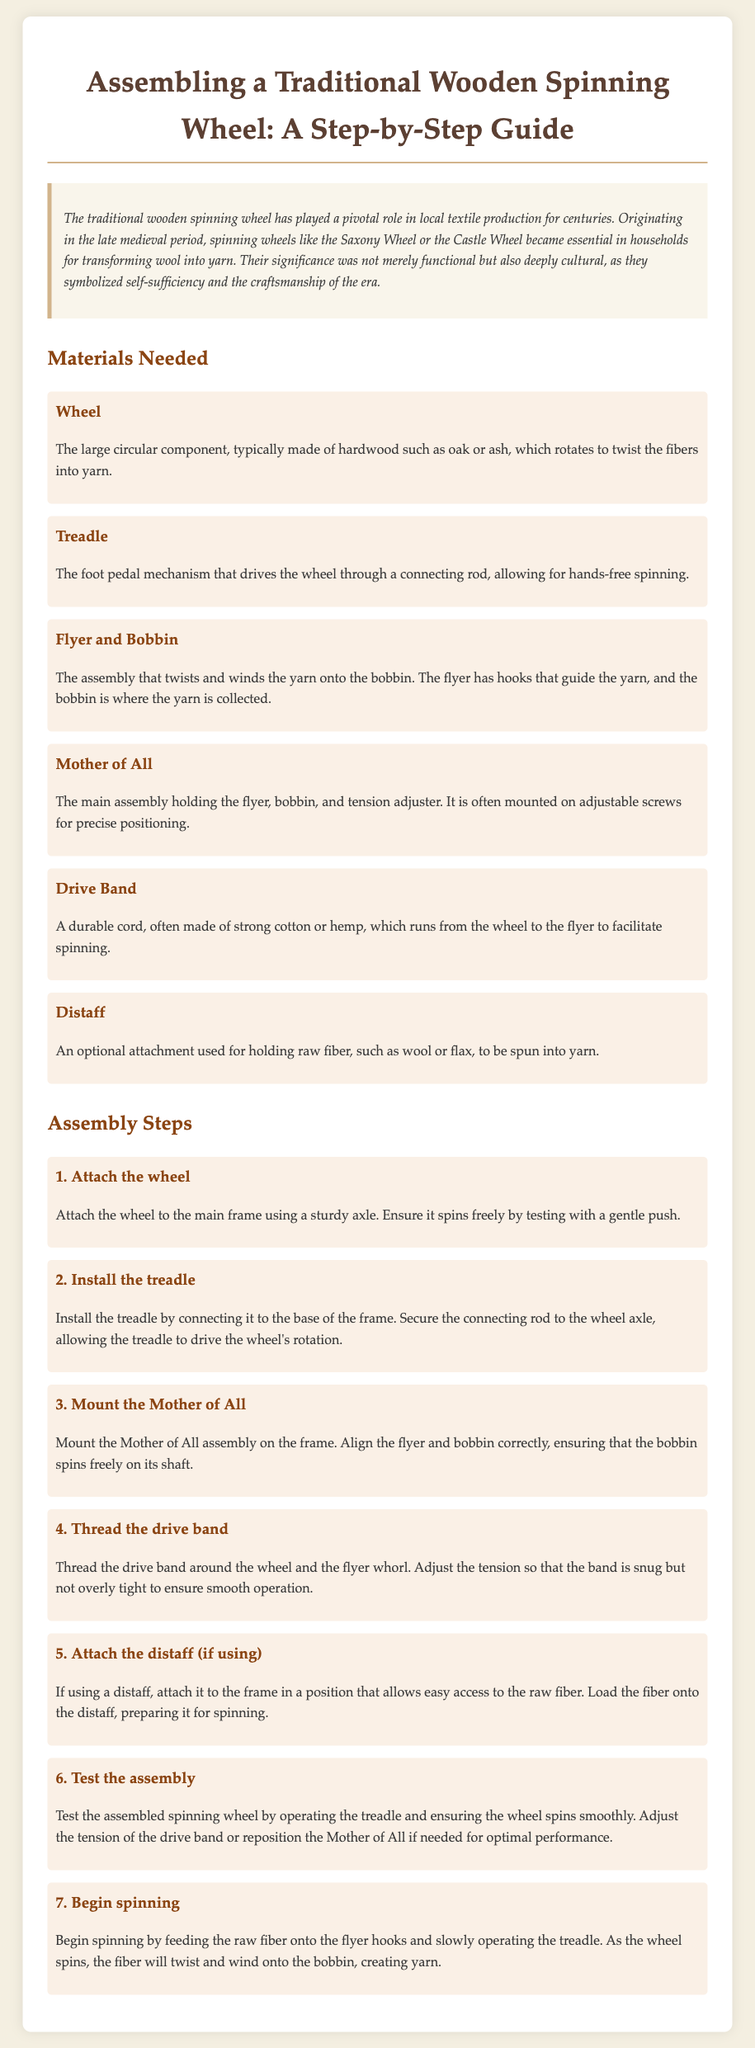what is the title of the document? The title of the document is stated prominently at the top, introducing the main topic of the content.
Answer: Assembling a Traditional Wooden Spinning Wheel: A Step-by-Step Guide what type of wood is the wheel made of? The document specifies the materials needed for assembly, mentioning the type of wood suitable for the wheel.
Answer: hardwood such as oak or ash how many assembly steps are provided in the document? The document lists each assembly step numerically, allowing us to count the total number of steps specified.
Answer: seven what is the purpose of the distaff? The materials section defines the role of the distaff in the spinning process.
Answer: holding raw fiber which component connects the treadle to the wheel? The assembly steps outline how the treadle interacts with the wheel during assembly.
Answer: connecting rod where is the Mother of All mounted? The steps detail the positioning of the Mother of All component in the assembly process.
Answer: on the frame what should be tested after assembly? The final assembly instructions include testing specific functionalities before starting to operate the spinning wheel.
Answer: the assembled spinning wheel why are spinning wheels culturally significant? The introductory paragraph of the document describes the broader historical and cultural importance of the spinning wheel.
Answer: self-sufficiency and the craftsmanship of the era 